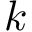<formula> <loc_0><loc_0><loc_500><loc_500>k</formula> 